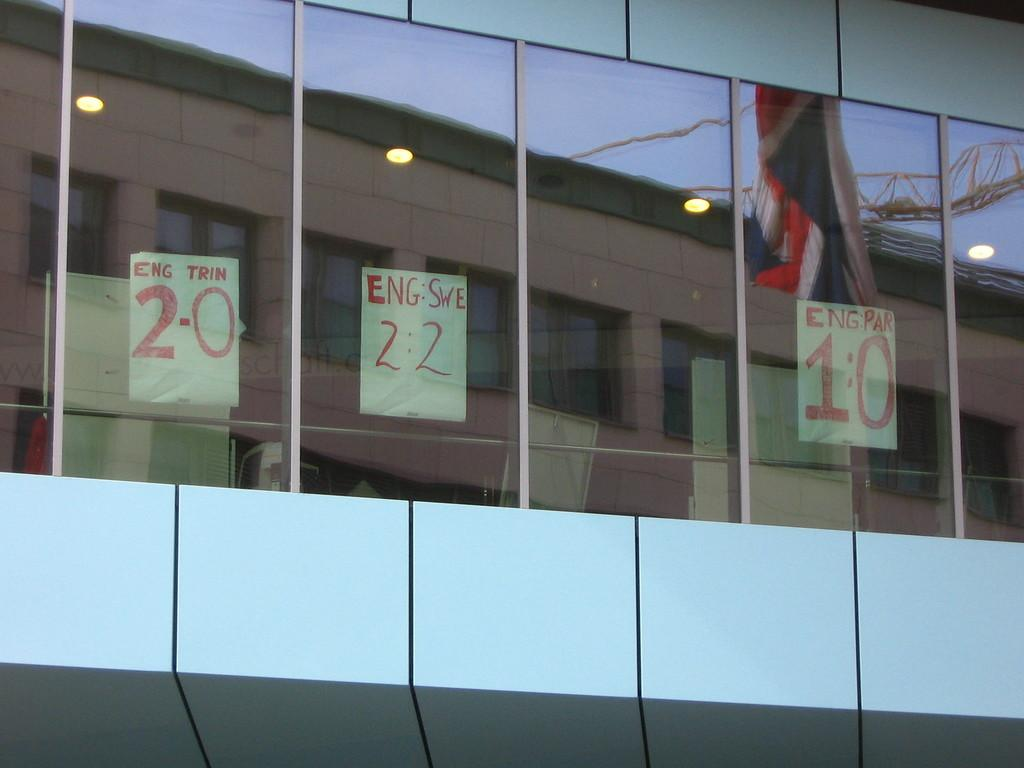What type of building is the main subject of the image? There is a glass building in the image. What can be seen inside the glass building? The glass building contains another building inside it. What other elements are present in the image? There are three posters with text and numbers, lights, a flag, rods, and objects visible in the glass building. Can you tell me how many dogs are playing with berries in the image? There are no dogs or berries present in the image. 